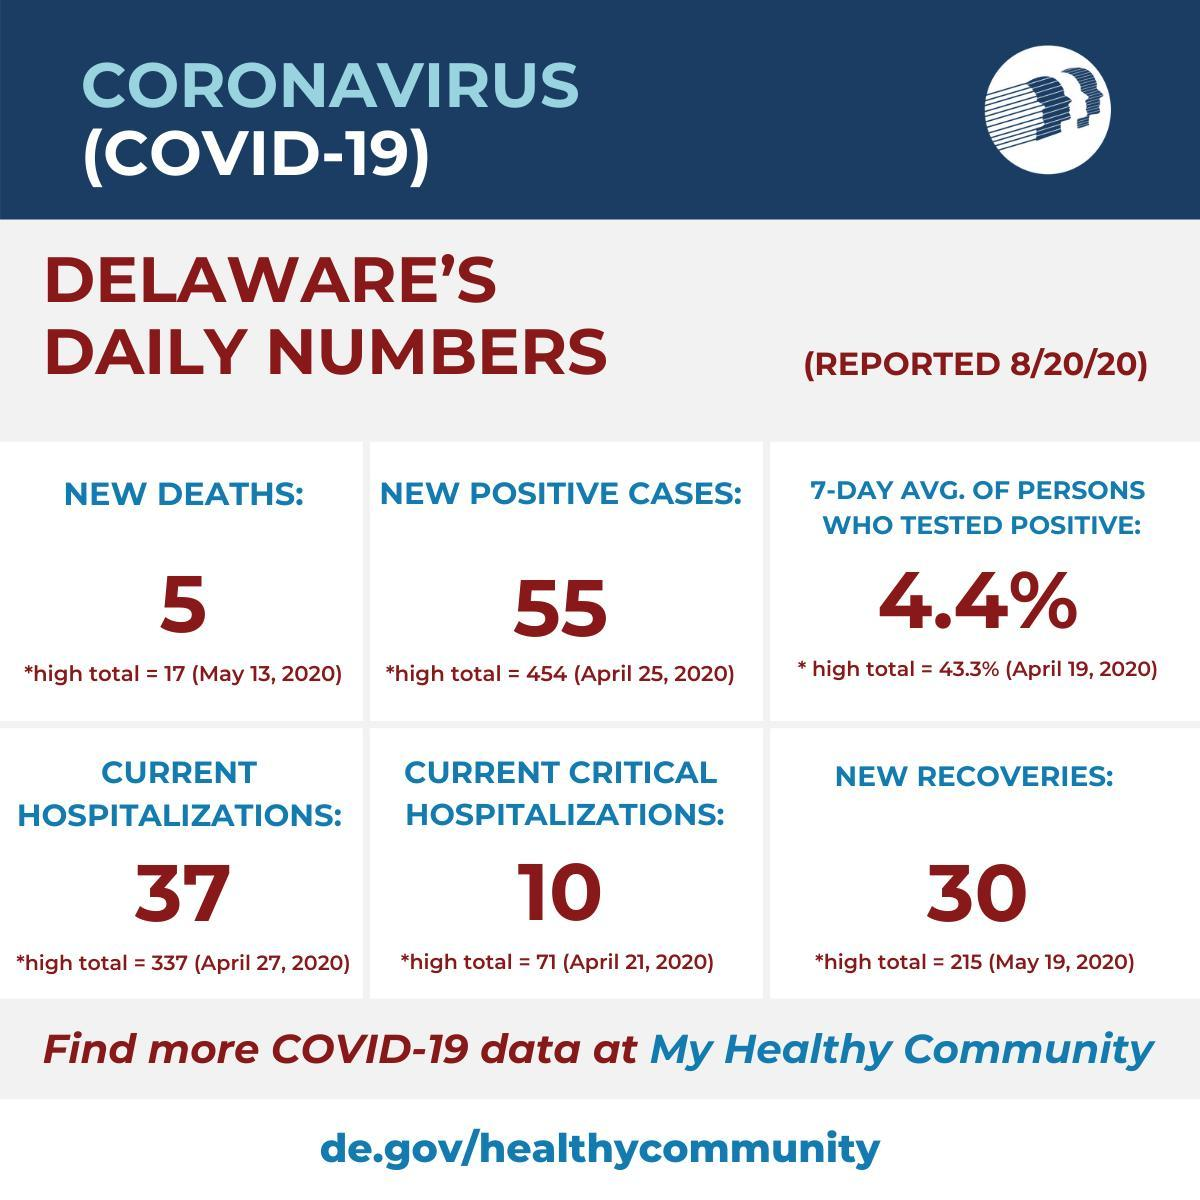When was the highest number of recoveries reported in Delaware?
Answer the question with a short phrase. May 19,2020 When was the highest number of critical hospitalizations reported in Delaware? April 21,2020 When was the highest number of hospitalizations reported in Delaware? April 27,2020 When was the highest new positive cases reported in Delaware? April 25,2020 What was the 7-day avg. of persons who tested positive reported on 8/20/20? 4.4% When was the highest number of deaths reported in Delaware? May 13,2020 